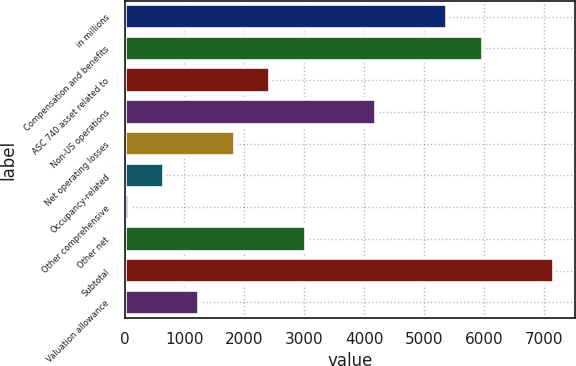Convert chart. <chart><loc_0><loc_0><loc_500><loc_500><bar_chart><fcel>in millions<fcel>Compensation and benefits<fcel>ASC 740 asset related to<fcel>Non-US operations<fcel>Net operating losses<fcel>Occupancy-related<fcel>Other comprehensive<fcel>Other net<fcel>Subtotal<fcel>Valuation allowance<nl><fcel>5388.9<fcel>5980<fcel>2433.4<fcel>4206.7<fcel>1842.3<fcel>660.1<fcel>69<fcel>3024.5<fcel>7162.2<fcel>1251.2<nl></chart> 